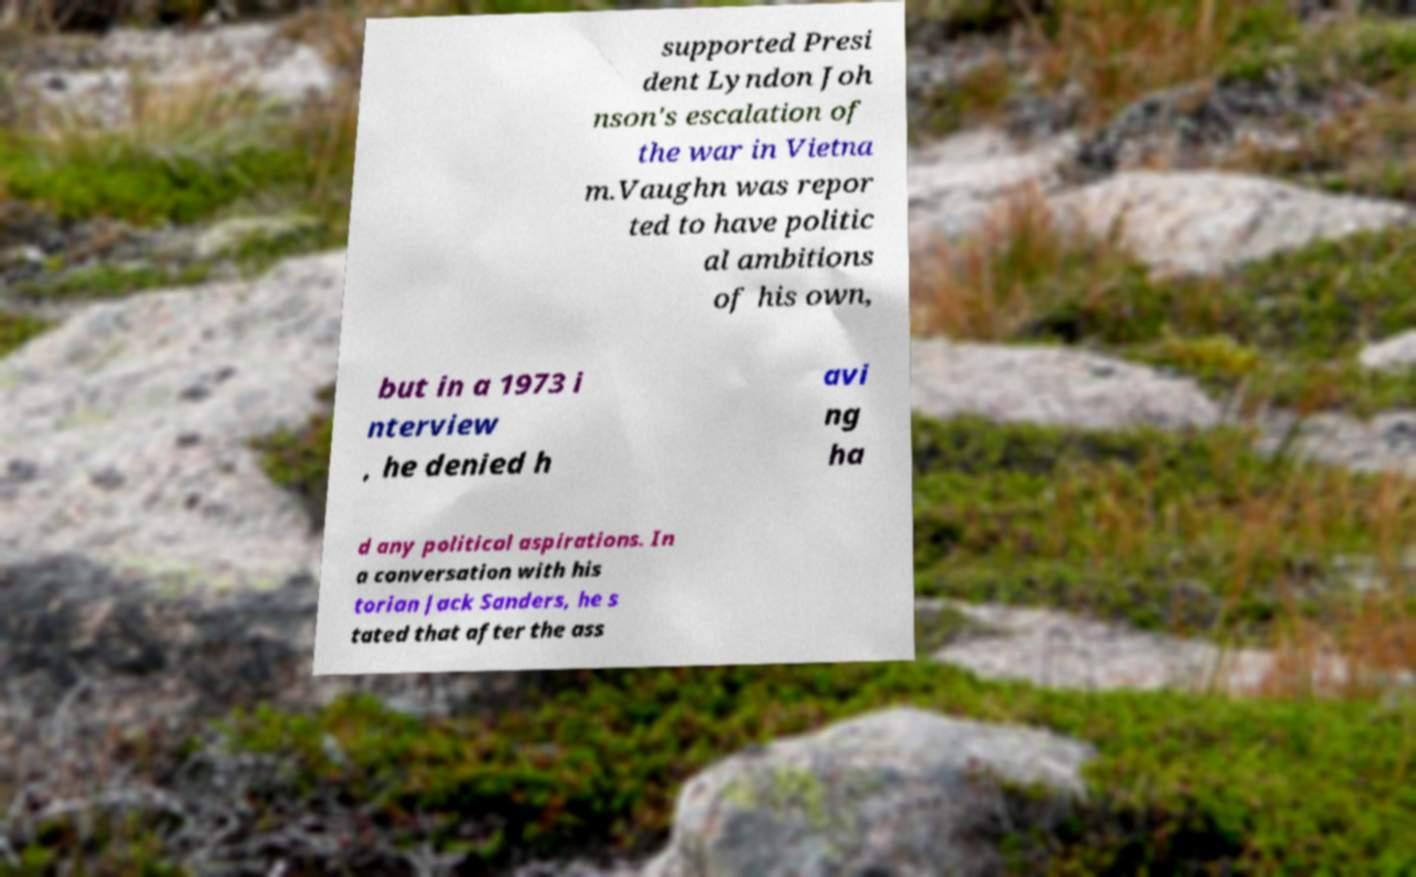Can you accurately transcribe the text from the provided image for me? supported Presi dent Lyndon Joh nson's escalation of the war in Vietna m.Vaughn was repor ted to have politic al ambitions of his own, but in a 1973 i nterview , he denied h avi ng ha d any political aspirations. In a conversation with his torian Jack Sanders, he s tated that after the ass 